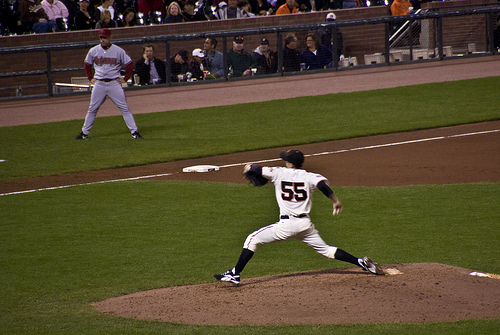Describe the emotions likely felt by the pitcher at this moment. The pitcher is likely feeling a mix of focus and determination, concentrating on delivering the best pitch possible. There might also be a hint of pressure or excitement, depending on the game's context. 